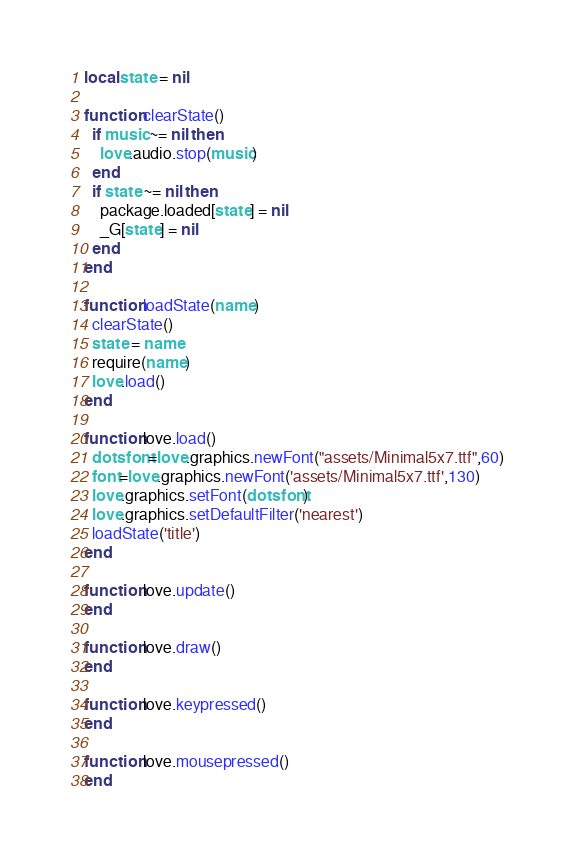<code> <loc_0><loc_0><loc_500><loc_500><_Lua_>local state = nil

function clearState()
  if music ~= nil then
    love.audio.stop(music)
  end
  if state ~= nil then
    package.loaded[state] = nil
    _G[state] = nil
  end
end

function loadState(name)
  clearState()
  state = name
  require(name)
  love.load()
end

function love.load()
  dotsfont=love.graphics.newFont("assets/Minimal5x7.ttf",60)
  font=love.graphics.newFont('assets/Minimal5x7.ttf',130)
  love.graphics.setFont(dotsfont)
  love.graphics.setDefaultFilter('nearest')
  loadState('title')
end

function love.update()
end

function love.draw()
end

function love.keypressed()
end

function love.mousepressed()
end
</code> 